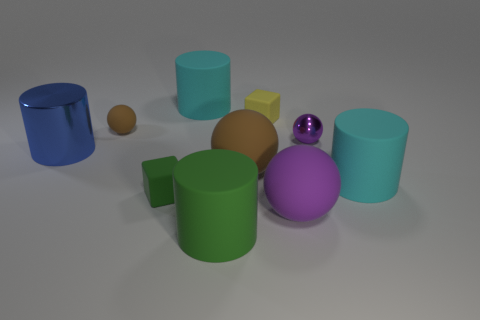Subtract all spheres. How many objects are left? 6 Subtract 0 brown cubes. How many objects are left? 10 Subtract all red matte spheres. Subtract all small rubber things. How many objects are left? 7 Add 5 big brown matte balls. How many big brown matte balls are left? 6 Add 3 tiny red matte cubes. How many tiny red matte cubes exist? 3 